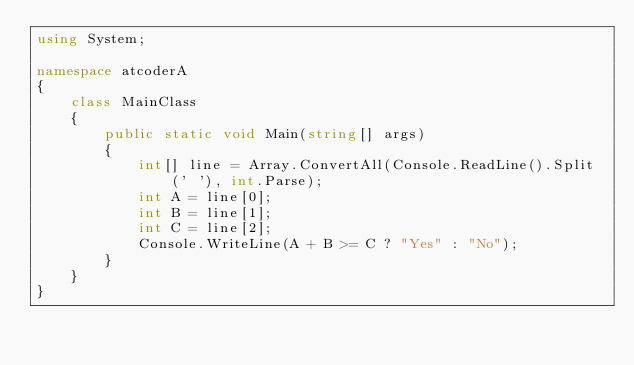<code> <loc_0><loc_0><loc_500><loc_500><_C#_>using System;

namespace atcoderA
{
    class MainClass
    {
        public static void Main(string[] args)
        {
            int[] line = Array.ConvertAll(Console.ReadLine().Split(' '), int.Parse);
            int A = line[0];
            int B = line[1];
            int C = line[2];
            Console.WriteLine(A + B >= C ? "Yes" : "No");
        }
    }
}</code> 